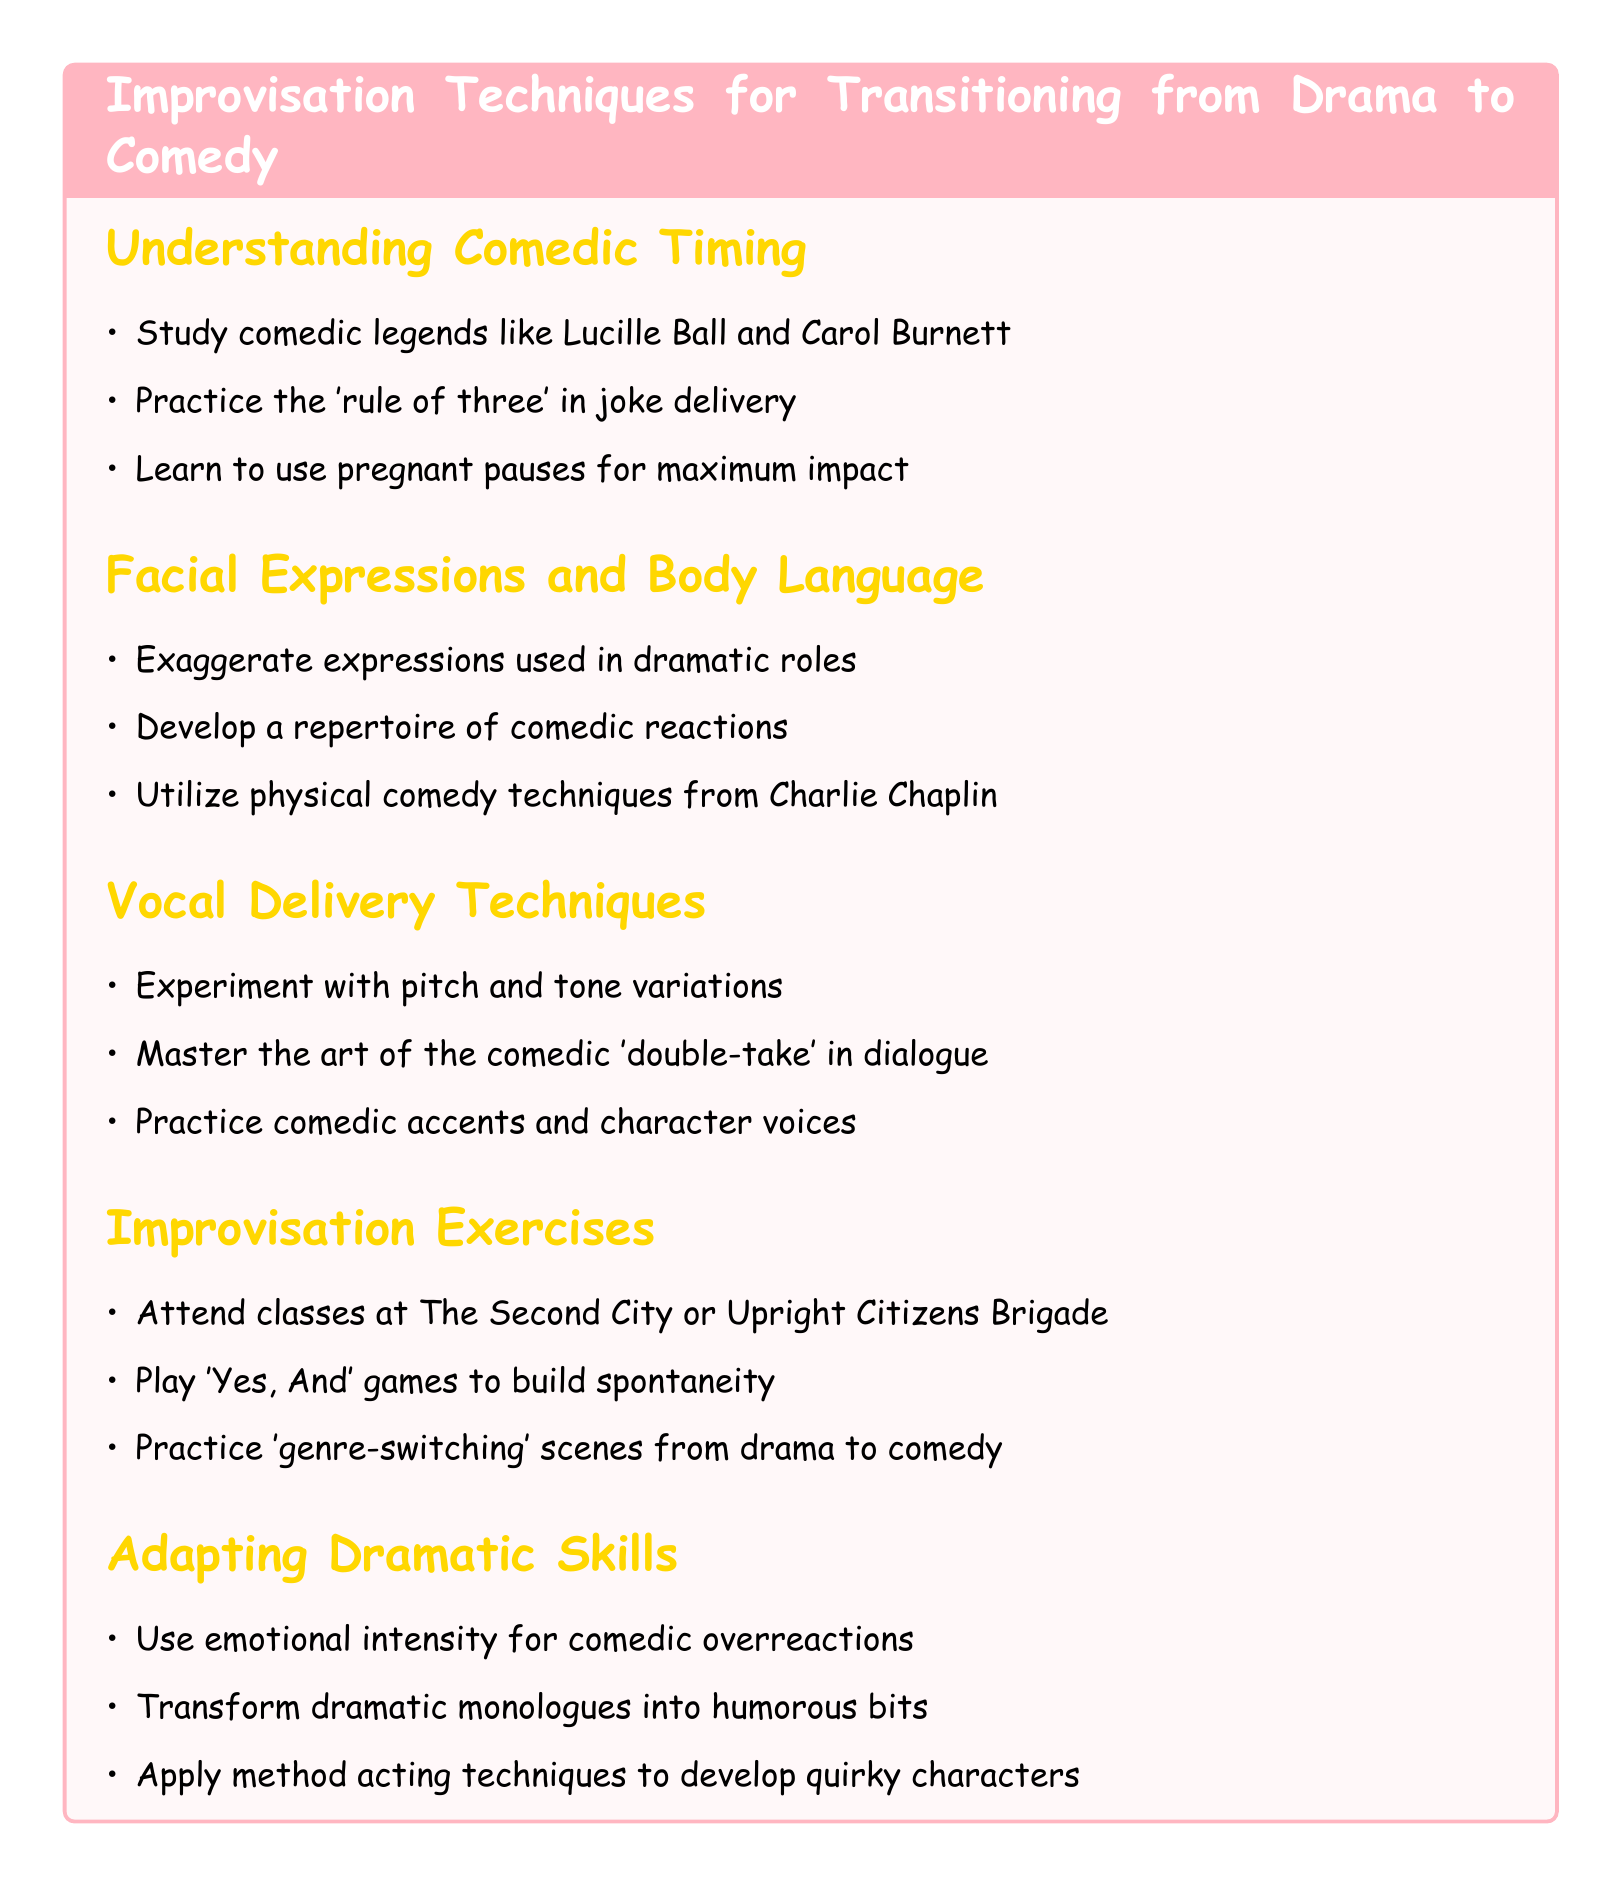What is the title of the document? The title is clearly stated at the top of the document and indicates the main focus of the content.
Answer: Improvisation Techniques for Transitioning from Drama to Comedy Who are two comedic legends to study for comedic timing? The document lists Lucille Ball and Carol Burnett as examples of comedic legends that can be used for study.
Answer: Lucille Ball and Carol Burnett What is the 'rule of three' related to? The 'rule of three' is referred to in the section about understanding comedic timing, specifically in the context of joke delivery.
Answer: Joke delivery Which technique from Charlie Chaplin is mentioned? The document highlights physical comedy techniques from Charlie Chaplin in the facial expressions and body language section.
Answer: Physical comedy techniques What is one exercise you can do to build spontaneity? The notes suggest playing 'Yes, And' games as an exercise to help with spontaneity in improvisation.
Answer: 'Yes, And' games How can dramatic skills be adapted for comedy? The document indicates that one way to adapt dramatic skills is to use emotional intensity for comedic overreactions.
Answer: Emotional intensity for comedic overreactions What should you experiment with in vocal delivery? The notes emphasize experimenting with pitch and tone variations to improve vocal delivery in comedy.
Answer: Pitch and tone variations Which organization offers classes for improvisation? The document mentions The Second City and Upright Citizens Brigade as places to attend classes focused on improvisation.
Answer: The Second City or Upright Citizens Brigade 